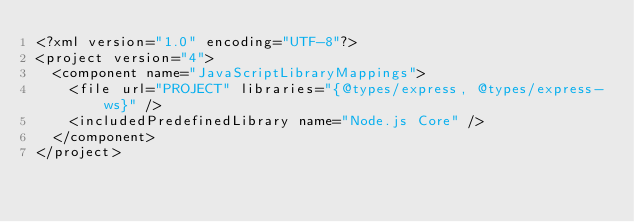<code> <loc_0><loc_0><loc_500><loc_500><_XML_><?xml version="1.0" encoding="UTF-8"?>
<project version="4">
  <component name="JavaScriptLibraryMappings">
    <file url="PROJECT" libraries="{@types/express, @types/express-ws}" />
    <includedPredefinedLibrary name="Node.js Core" />
  </component>
</project></code> 